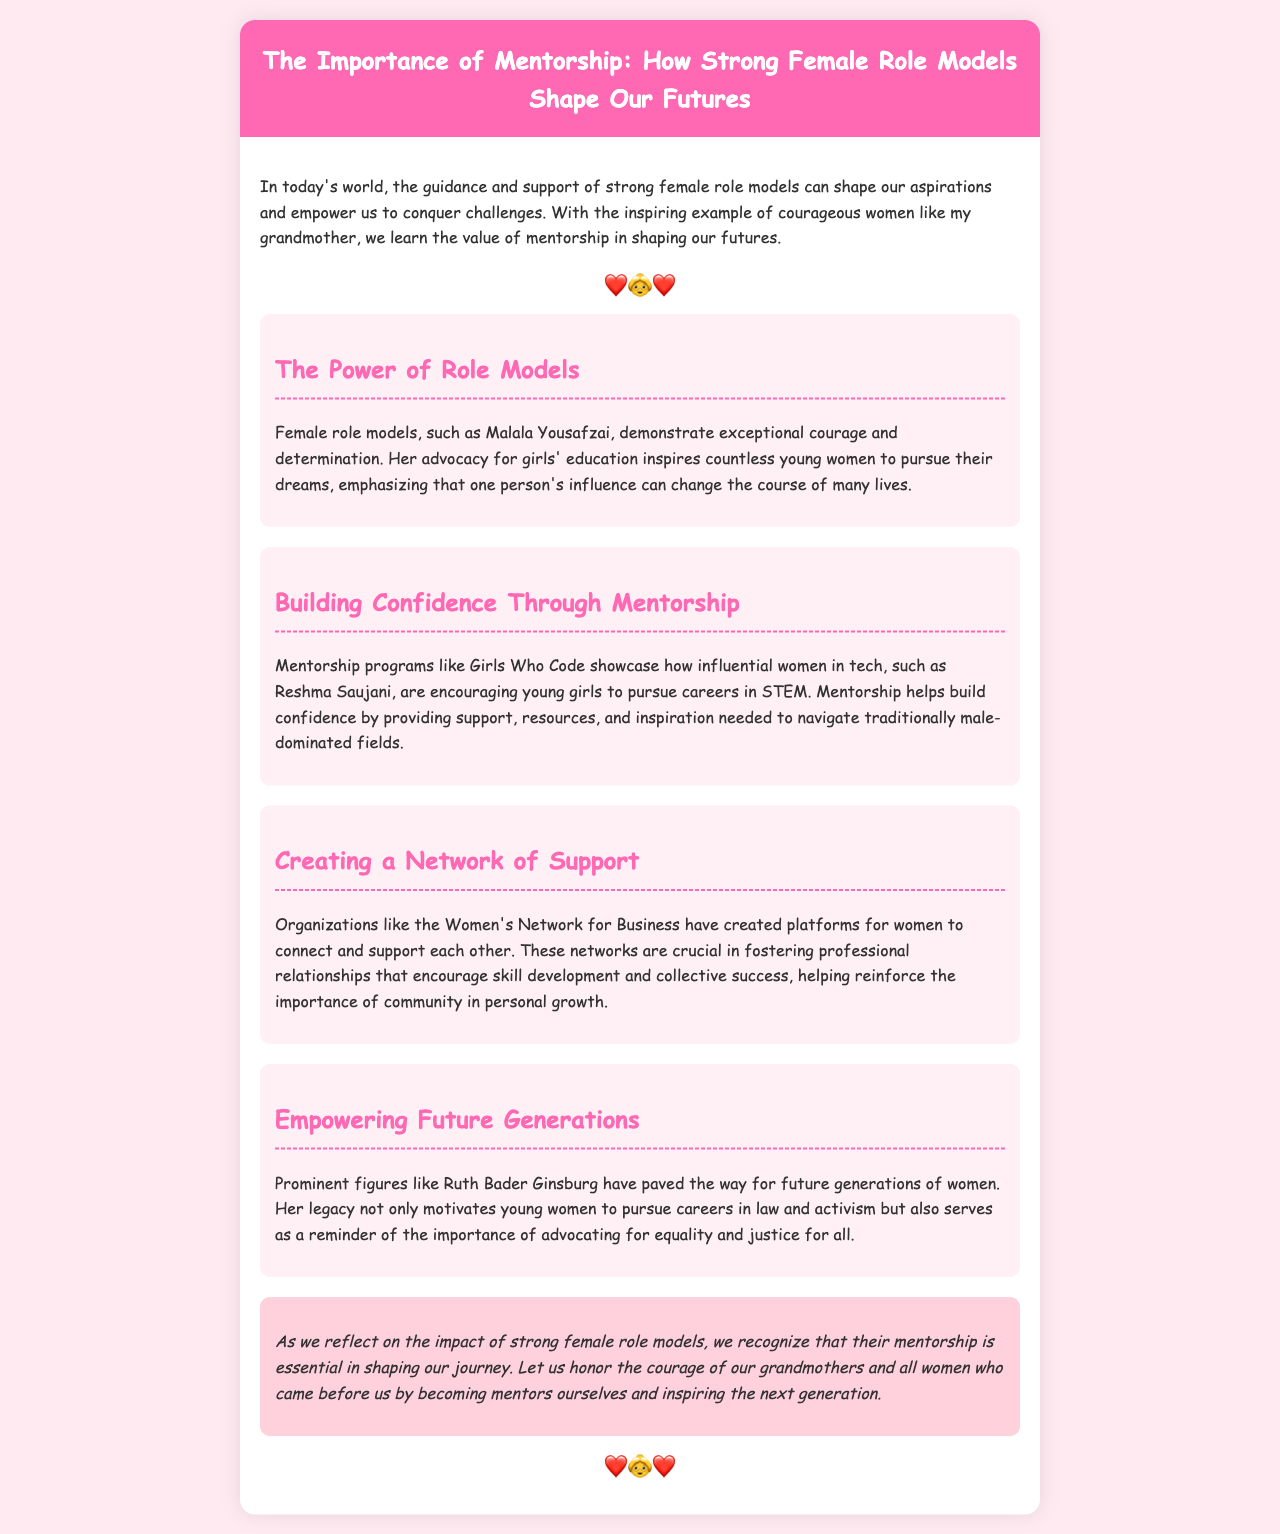What is the title of the newsletter? The title is prominently displayed in the header of the document.
Answer: The Importance of Mentorship: How Strong Female Role Models Shape Our Futures Who is mentioned as an inspiring role model for girls' education? The document highlights notable female figures who serve as role models.
Answer: Malala Yousafzai What organization is mentioned that helps girls pursue careers in tech? The document provides an example of a mentorship program that supports girls in STEM fields.
Answer: Girls Who Code Which former Supreme Court Justice is referenced as a role model? The document mentions influential women who have made significant impacts in their fields.
Answer: Ruth Bader Ginsburg What color is used as the background for the header? The document specifies the design elements, including background colors.
Answer: Pink How do mentorship programs help young girls? The document discusses the benefits of mentorship and its effects on confidence and career choices.
Answer: Build confidence What is emphasized as crucial for personal growth? The document highlights specific factors contributing to growth and development among women.
Answer: Community What does the conclusion encourage readers to do? The document wraps up with a call to action inspired by the themes presented.
Answer: Become mentors 